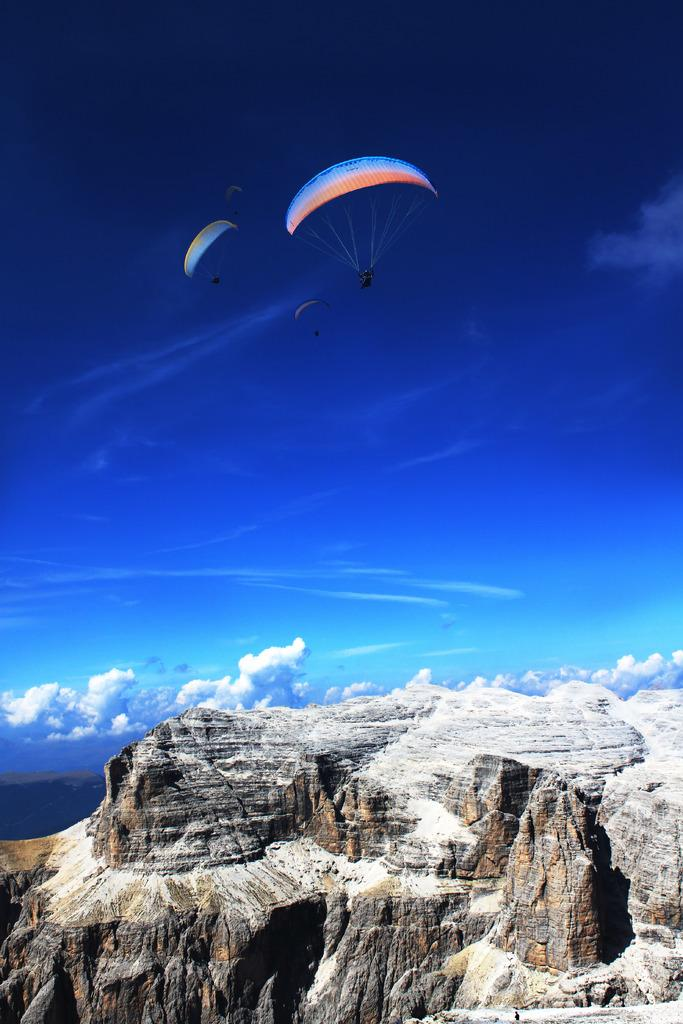What can be seen in the sky in the image? There are two parachutes in the image. What are the parachutes doing in the image? The parachutes are flying in the air. What is visible below the parachutes in the image? There is a big hill below the parachutes. What type of amusement can be seen in the image? There is no amusement present in the image; it features two parachutes flying in the air and a big hill below them. How many boys are visible in the image? There are no boys visible in the image. 